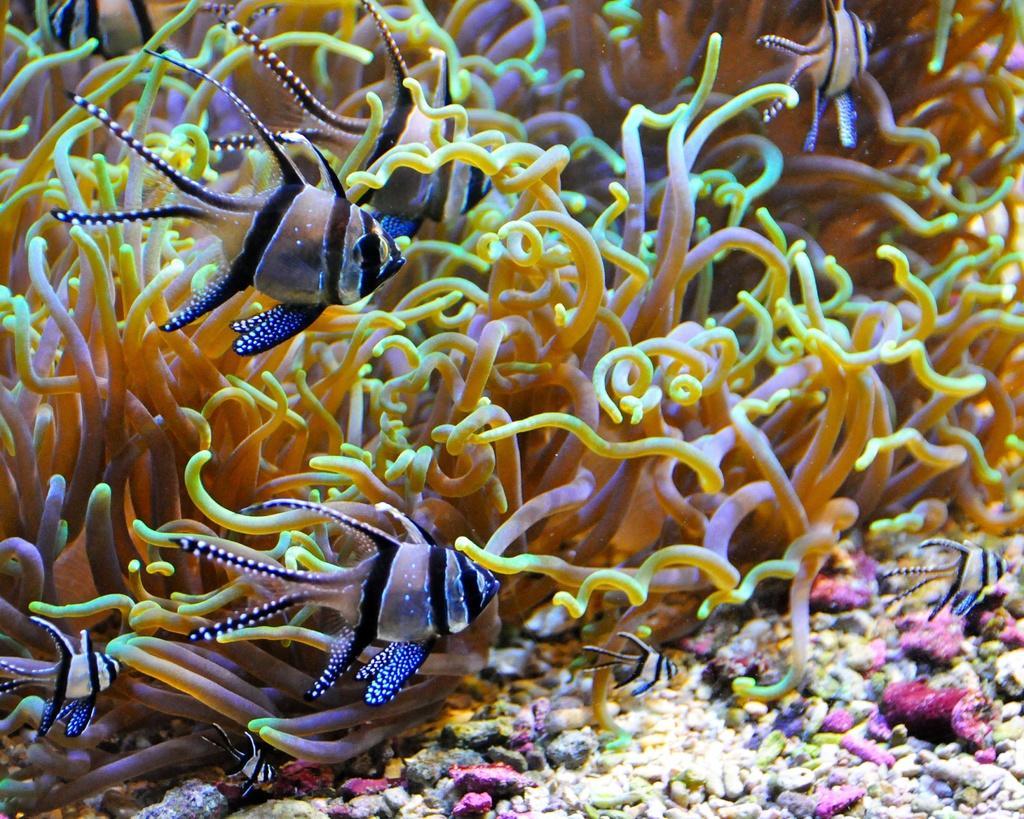Please provide a concise description of this image. This picture is taken inside the water. In this image, we can see some fishes and some water mammals. At the bottom, we can see some stones. 